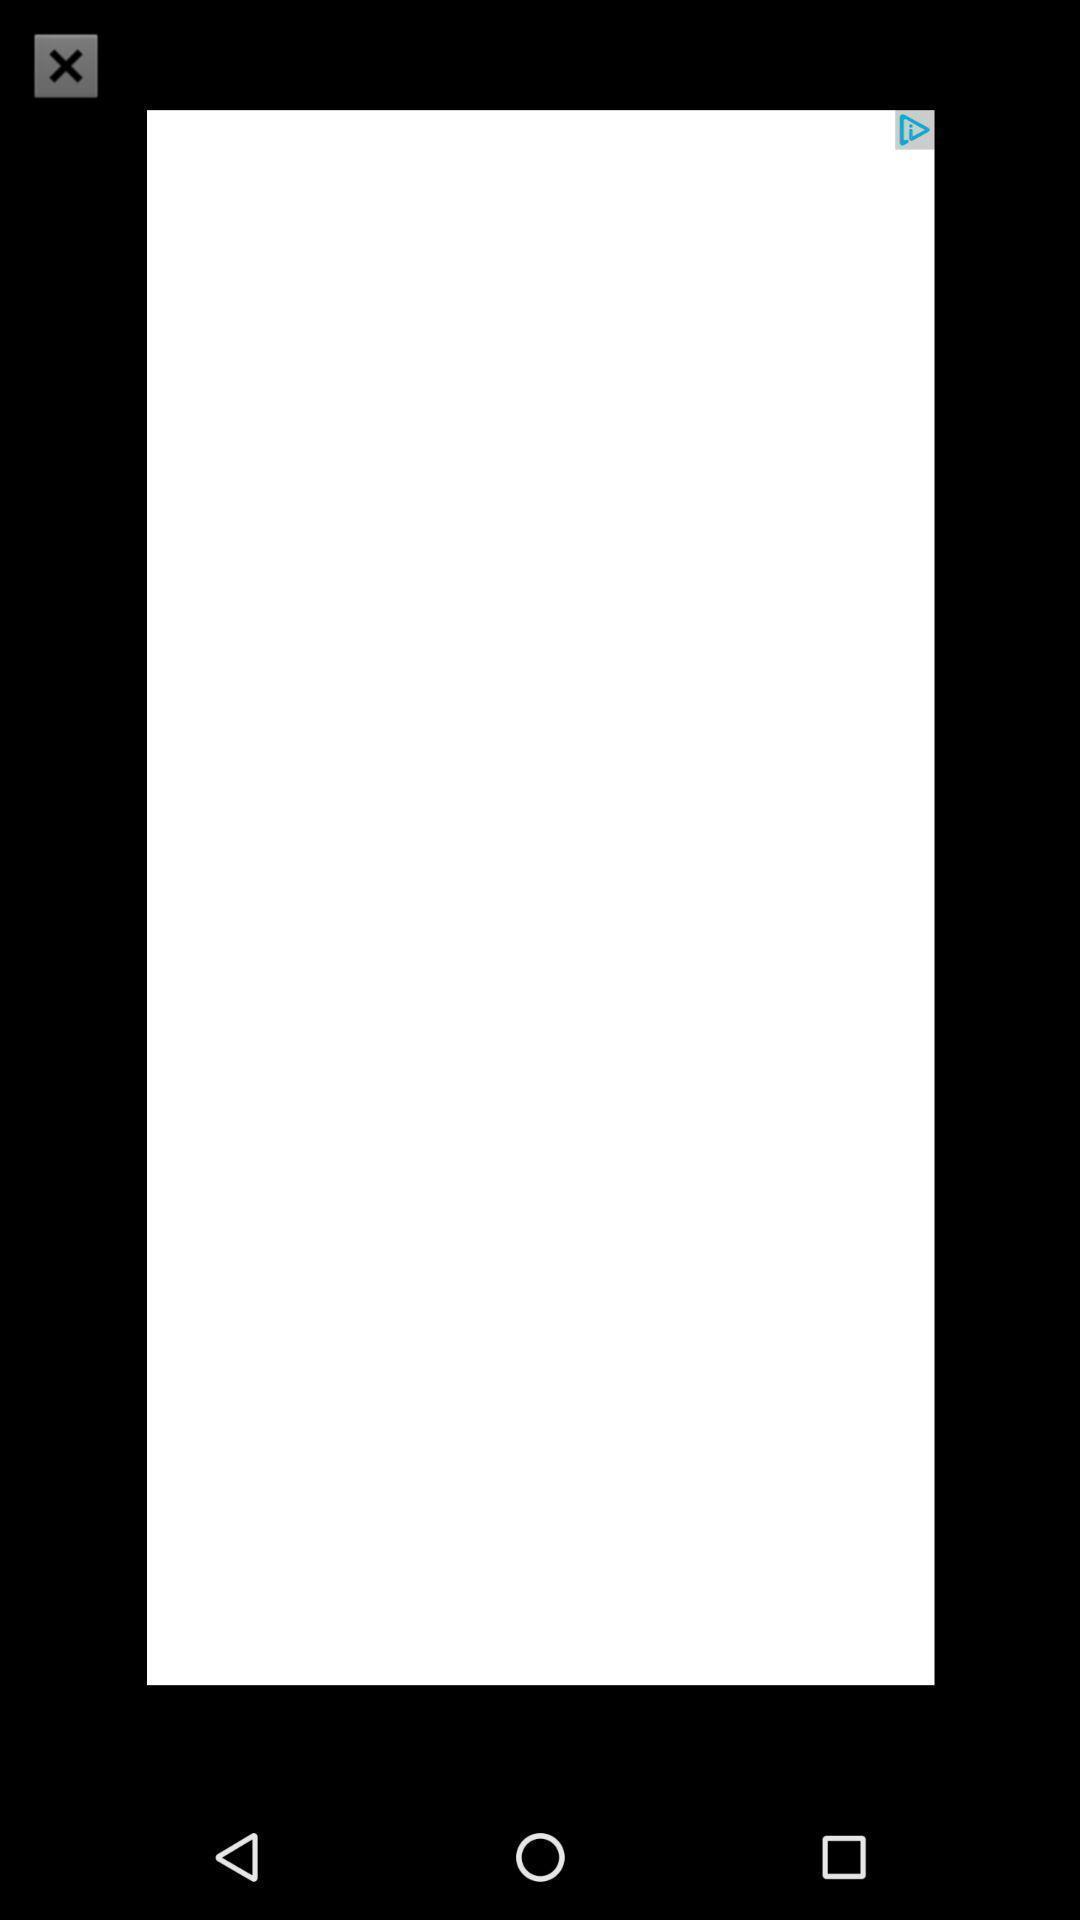Summarize the main components in this picture. Wight page of the app. 